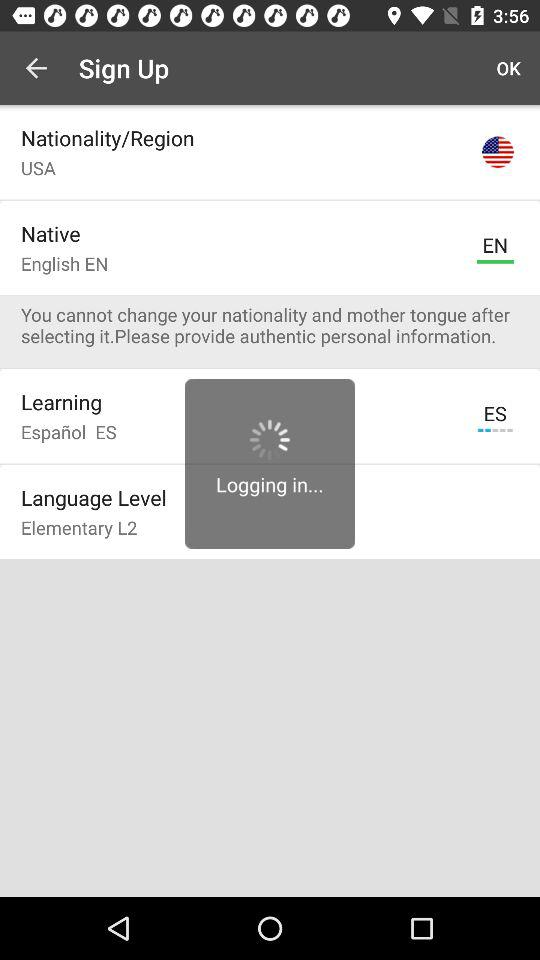How can we log in? You can log in with "Facebook". 